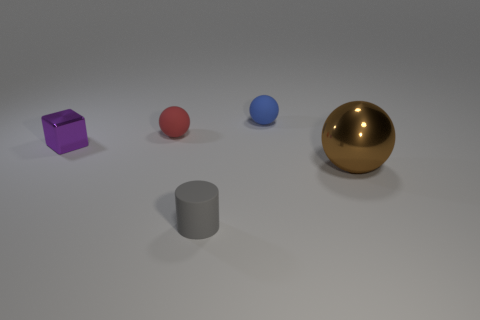Is the small cube the same color as the shiny sphere?
Give a very brief answer. No. How many other things are there of the same size as the blue rubber thing?
Ensure brevity in your answer.  3. Do the small ball on the left side of the tiny rubber cylinder and the tiny blue ball to the right of the small red object have the same material?
Offer a terse response. Yes. How many tiny matte balls are behind the blue ball?
Keep it short and to the point. 0. What number of purple objects are either tiny cylinders or small rubber things?
Your answer should be very brief. 0. What material is the red thing that is the same size as the gray rubber cylinder?
Give a very brief answer. Rubber. There is a object that is both in front of the purple thing and behind the gray thing; what is its shape?
Give a very brief answer. Sphere. There is a cylinder that is the same size as the purple metal block; what color is it?
Offer a terse response. Gray. Is the size of the thing to the left of the red ball the same as the rubber thing that is right of the small gray thing?
Your response must be concise. Yes. What is the size of the metal thing in front of the purple metal object behind the small thing in front of the small metal block?
Ensure brevity in your answer.  Large. 